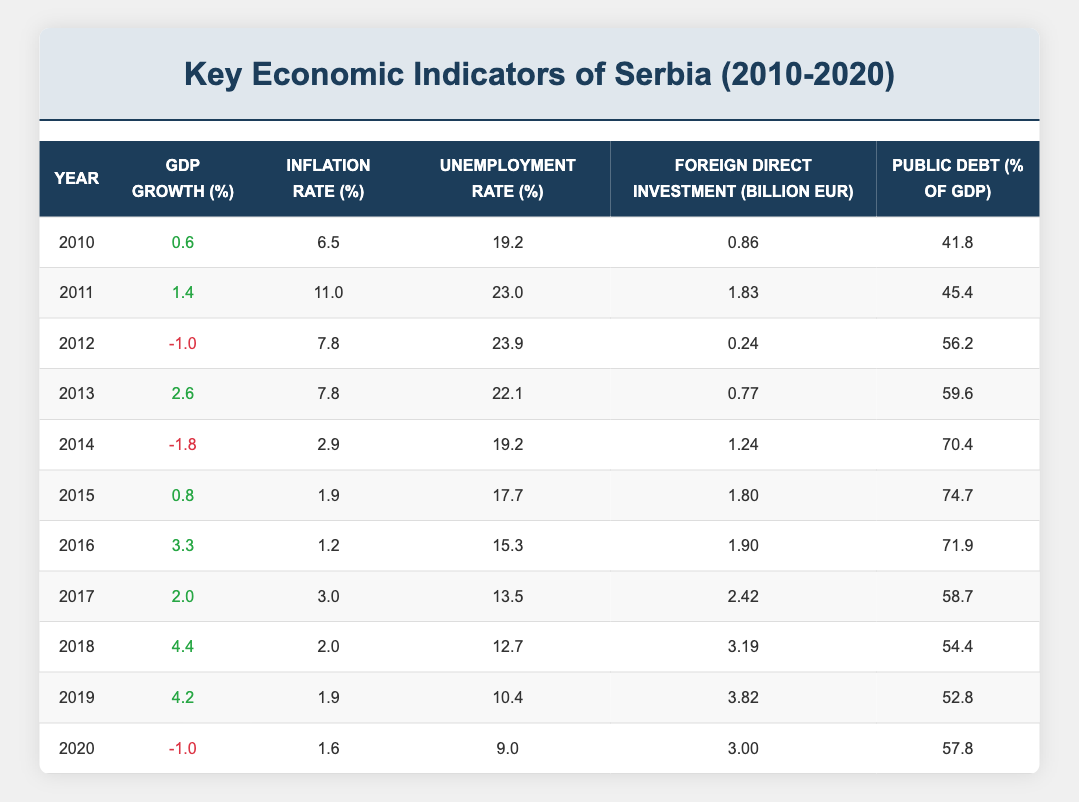What was the GDP growth rate in 2017? The table shows the GDP growth rate for each year listed. In 2017, the GDP growth rate is 2.0%.
Answer: 2.0% Which year had the highest inflation rate? By looking down the inflation rate column, 2011 has the highest value at 11.0%.
Answer: 2011 What is the average unemployment rate from 2010 to 2020? To find the average unemployment rate, sum the unemployment rates from each year (19.2 + 23.0 + 23.9 + 22.1 + 19.2 + 17.7 + 15.3 + 13.5 + 12.7 + 10.4 + 9.0) = 174.6, then divide by the number of years (11). So, 174.6 / 11 = 15.96%.
Answer: 15.96% Did Serbia experience a negative GDP growth rate in more than two years from 2010 to 2020? Checking the negative GDP growth rates, we find -1.0% in 2012 and 2020, and -1.8% in 2014. That makes a total of three years with negative growth.
Answer: Yes What was the change in the Foreign Direct Investment (FDI) from 2010 to 2020? The FDI in 2010 was 0.86 billion EUR and in 2020 it was 3.00 billion EUR. The change is 3.00 - 0.86 = 2.14 billion EUR, indicating an increase.
Answer: 2.14 billion EUR 